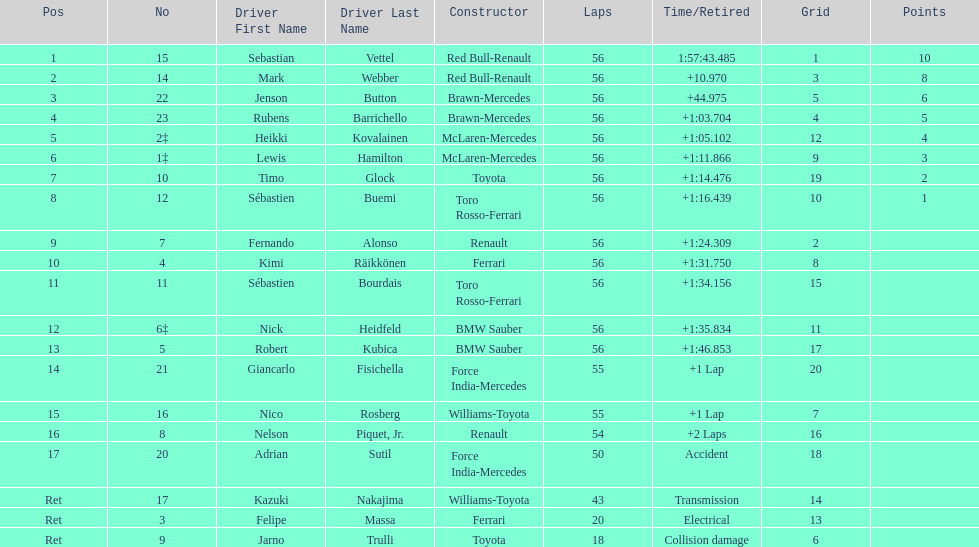What name is just previous to kazuki nakjima on the list? Adrian Sutil. 